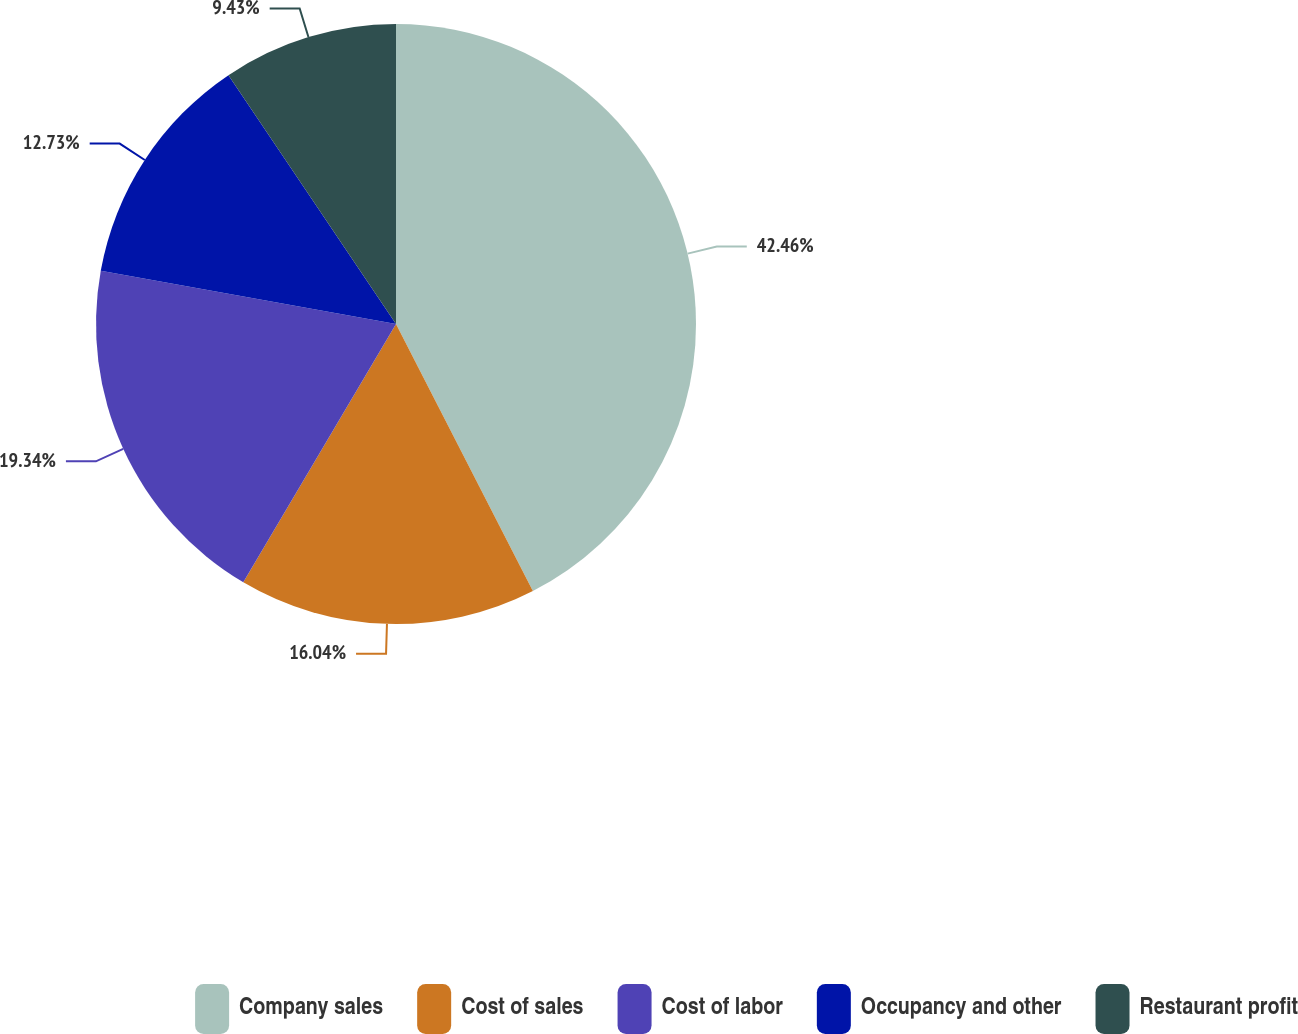Convert chart to OTSL. <chart><loc_0><loc_0><loc_500><loc_500><pie_chart><fcel>Company sales<fcel>Cost of sales<fcel>Cost of labor<fcel>Occupancy and other<fcel>Restaurant profit<nl><fcel>42.46%<fcel>16.04%<fcel>19.34%<fcel>12.73%<fcel>9.43%<nl></chart> 